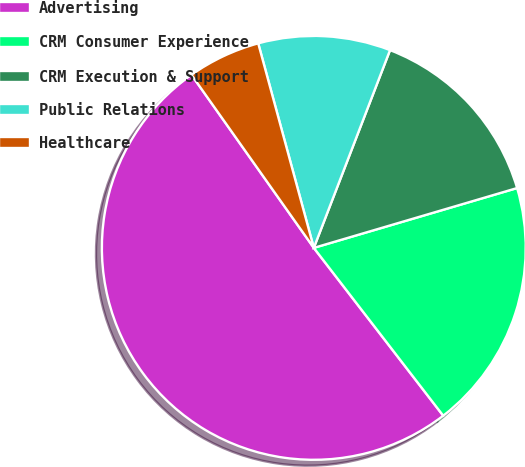Convert chart. <chart><loc_0><loc_0><loc_500><loc_500><pie_chart><fcel>Advertising<fcel>CRM Consumer Experience<fcel>CRM Execution & Support<fcel>Public Relations<fcel>Healthcare<nl><fcel>50.66%<fcel>19.1%<fcel>14.59%<fcel>10.08%<fcel>5.57%<nl></chart> 